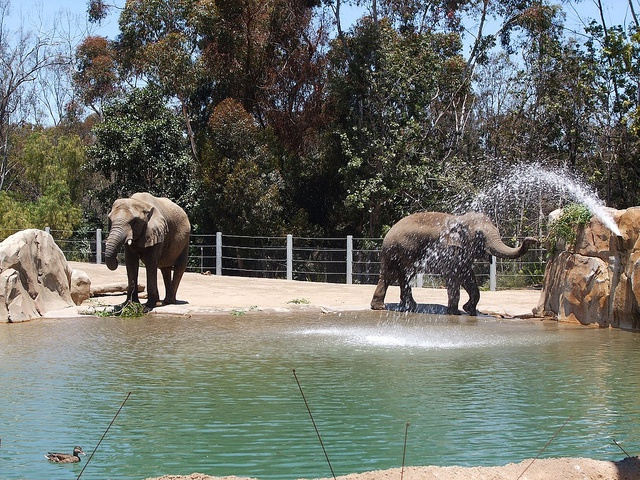Describe the objects in this image and their specific colors. I can see elephant in lightblue, black, gray, darkgray, and lightgray tones, elephant in lightblue, black, gray, darkgray, and tan tones, and bird in lightblue, gray, darkgray, and black tones in this image. 